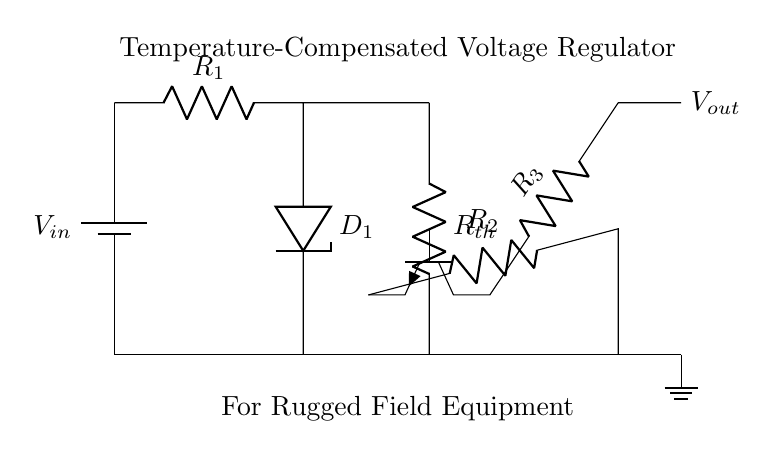What is the input voltage of this regulator? The input voltage is identified as $V_{in}$, labeled on the battery symbol in the diagram at the top left.
Answer: $V_{in}$ What type of diode is used in this circuit? The diode in this circuit is labeled as $D_1$, which is a Zener diode based on the common symbols used in voltage regulation circuits.
Answer: Zener diode What is the purpose of the thermistor ($R_{th}$) in this design? The thermistor is included to provide temperature compensation; it adjusts the voltage output based on temperature changes, helping maintain stability in rugged environments.
Answer: Temperature compensation What is the configuration of the transistor in this circuit? The transistor is configured as a common emitter; the input is at the base, and the output is at the collector, which is a standard configuration for voltage regulation.
Answer: Common emitter What role does resistor $R_3$ play in the circuit? Resistor $R_3$ is connected to the collector of the transistor, and it is likely used to set the output voltage by dropping the excess voltage beyond what is regulated by the Zener diode.
Answer: Sets output voltage What happens to the output voltage if the input voltage increases? If $V_{in}$ increases, the output voltage $V_{out}$ may also increase unless the Zener diode regulates it; the thermistor's role is to modify the behavior under varying temperatures, potentially stabilizing $V_{out}$.
Answer: May increase unless regulated What is the significance of the label 'For Rugged Field Equipment'? The label indicates that the regulator is designed for durability and reliable performance in difficult environmental conditions, emphasizing robustness and temperature adaptability.
Answer: Durability and reliability 